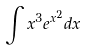<formula> <loc_0><loc_0><loc_500><loc_500>\int x ^ { 3 } e ^ { x ^ { 2 } } d x</formula> 